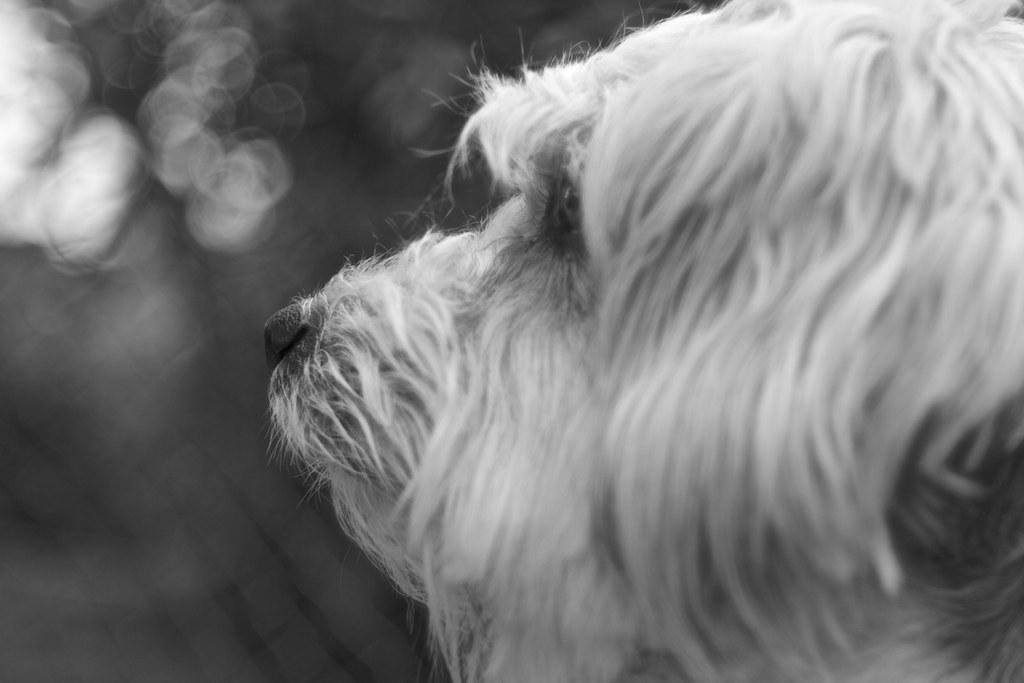In one or two sentences, can you explain what this image depicts? This is a black and white picture. In this picture, we see a white dog. In the background, it is black in color. This picture is blurred in the background. 